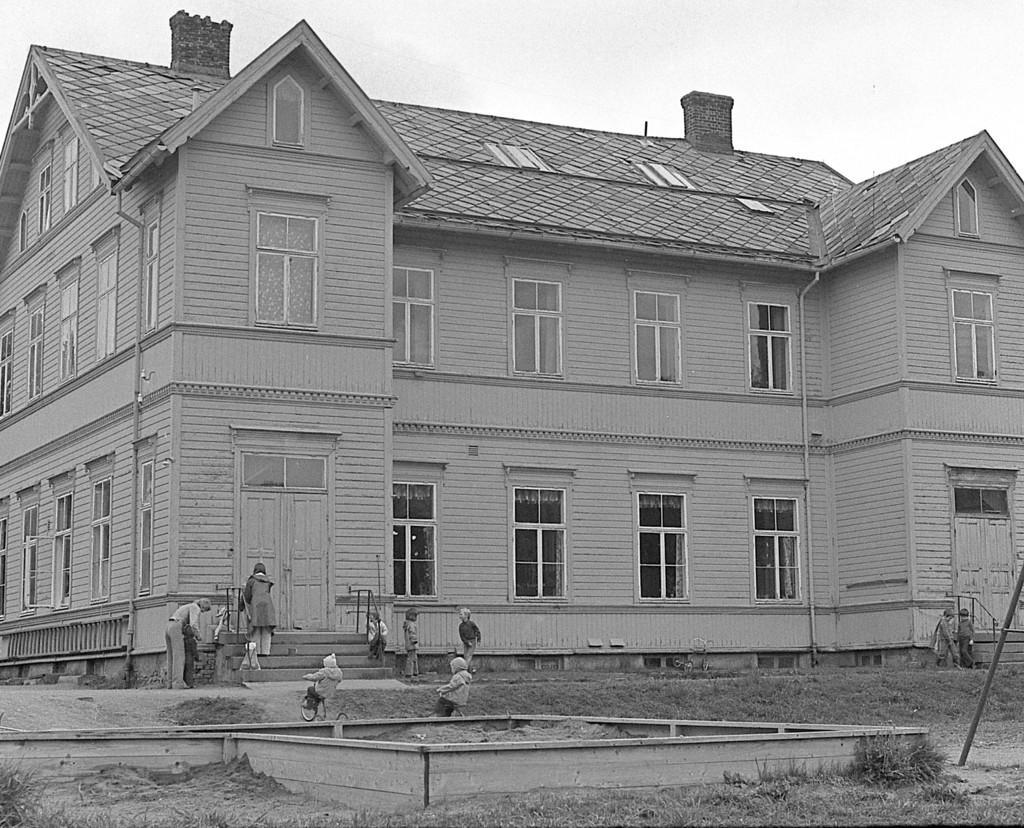Can you describe this image briefly? In this picture we can see a building and a few windows on it. There are few people on the stairs and some people are riding on a bicycle. We can see a pole on the right side. Some grass is visible on the ground. 